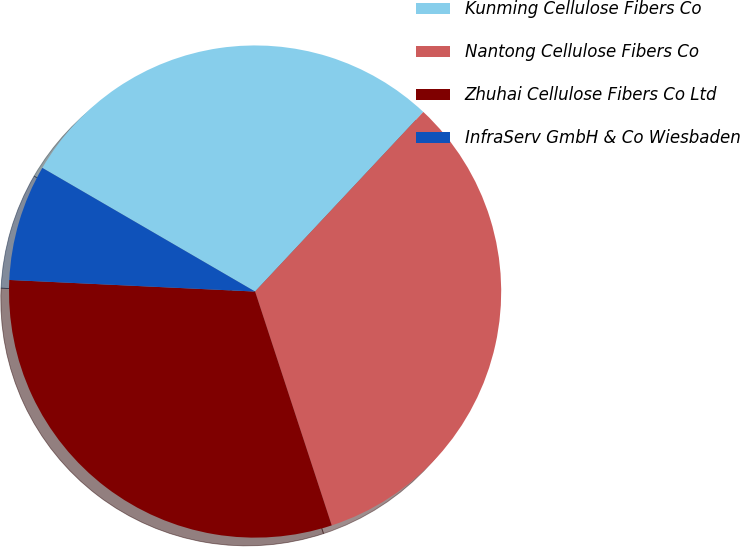Convert chart. <chart><loc_0><loc_0><loc_500><loc_500><pie_chart><fcel>Kunming Cellulose Fibers Co<fcel>Nantong Cellulose Fibers Co<fcel>Zhuhai Cellulose Fibers Co Ltd<fcel>InfraServ GmbH & Co Wiesbaden<nl><fcel>28.6%<fcel>32.98%<fcel>30.79%<fcel>7.63%<nl></chart> 